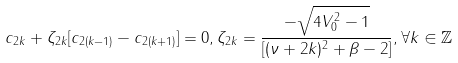<formula> <loc_0><loc_0><loc_500><loc_500>c _ { 2 k } + \zeta _ { 2 k } [ c _ { 2 ( k - 1 ) } - c _ { 2 ( k + 1 ) } ] = 0 , \zeta _ { 2 k } = \frac { - \sqrt { 4 V _ { 0 } ^ { 2 } - 1 } } { [ ( \nu + 2 k ) ^ { 2 } + \beta - 2 ] } , \forall k \in \mathbb { Z }</formula> 